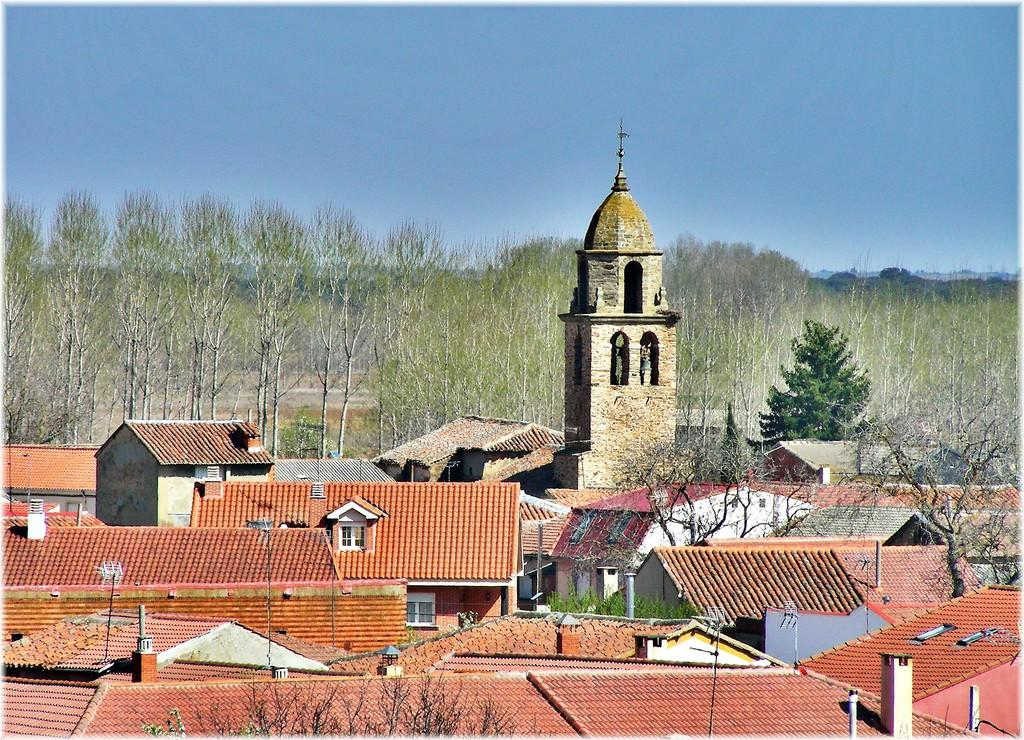What type of structures can be seen in the image? There are houses in the image. What architectural feature is visible in the houses? There are windows visible in the image. What type of vegetation is present in the image? There are green trees in the image. What color is the sky in the image? The sky is blue in the image. How many drops of water can be seen falling from the sky in the image? There are no drops of water visible in the image; the sky is blue. Are any of the people in the image wearing masks? There are no people visible in the image, so it cannot be determined if anyone is wearing a mask. 